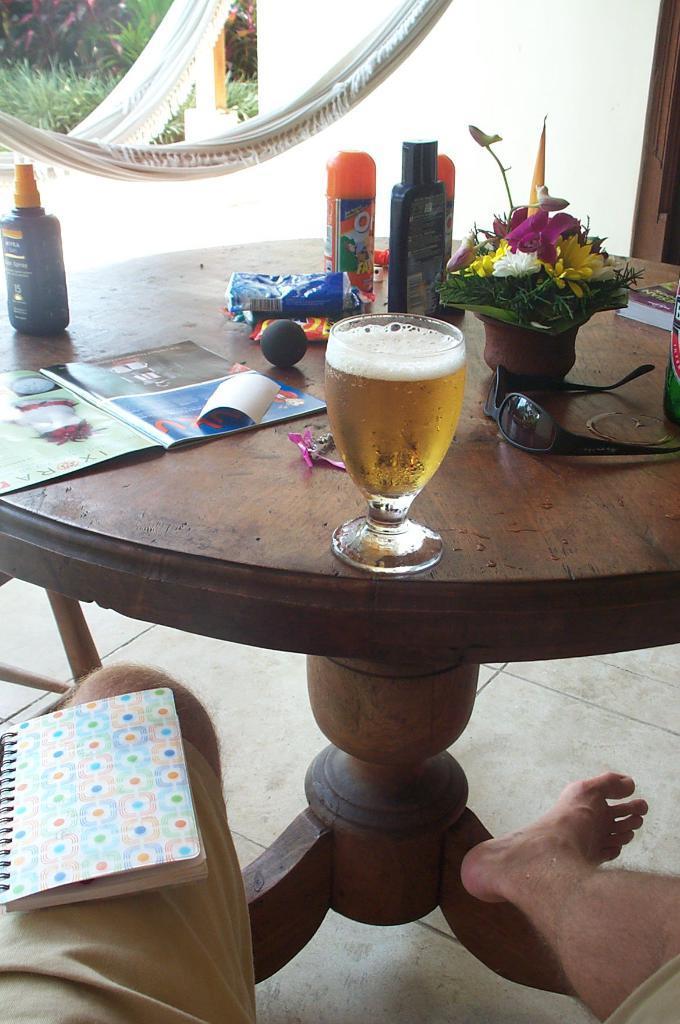How would you summarize this image in a sentence or two? In this picture we can see a table. On the table there is a glass, book, bottles, goggles, and a flower vase. This is floor and there is a book. 